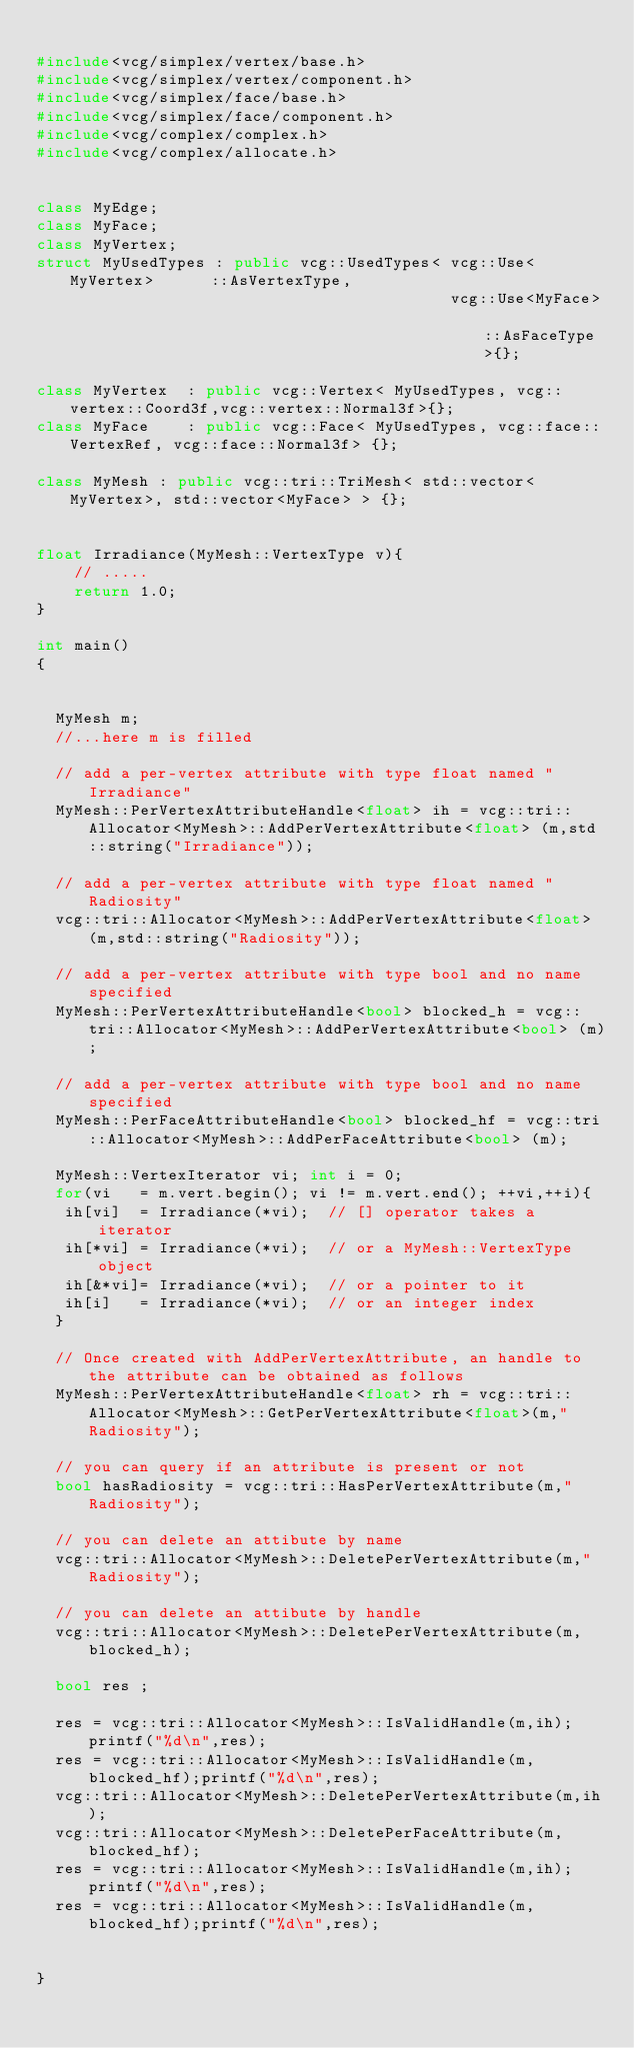Convert code to text. <code><loc_0><loc_0><loc_500><loc_500><_C++_>
#include<vcg/simplex/vertex/base.h>
#include<vcg/simplex/vertex/component.h>
#include<vcg/simplex/face/base.h>
#include<vcg/simplex/face/component.h>
#include<vcg/complex/complex.h>
#include<vcg/complex/allocate.h>


class MyEdge;
class MyFace;
class MyVertex;
struct MyUsedTypes : public vcg::UsedTypes<	vcg::Use<MyVertex>		::AsVertexType,
											vcg::Use<MyFace>			::AsFaceType>{};

class MyVertex  : public vcg::Vertex< MyUsedTypes, vcg::vertex::Coord3f,vcg::vertex::Normal3f>{};
class MyFace    : public vcg::Face< MyUsedTypes, vcg::face::VertexRef, vcg::face::Normal3f> {};

class MyMesh : public vcg::tri::TriMesh< std::vector<MyVertex>, std::vector<MyFace> > {};

 
float Irradiance(MyMesh::VertexType v){
	// .....
	return 1.0;
}

int main()
{


  MyMesh m;
  //...here m is filled
  
  // add a per-vertex attribute with type float named "Irradiance"
  MyMesh::PerVertexAttributeHandle<float> ih = vcg::tri::Allocator<MyMesh>::AddPerVertexAttribute<float> (m,std::string("Irradiance"));

  // add a per-vertex attribute with type float named "Radiosity"   
  vcg::tri::Allocator<MyMesh>::AddPerVertexAttribute<float> (m,std::string("Radiosity"));
 
  // add a per-vertex attribute with type bool and no name specified
  MyMesh::PerVertexAttributeHandle<bool> blocked_h = vcg::tri::Allocator<MyMesh>::AddPerVertexAttribute<bool> (m); 
  
  // add a per-vertex attribute with type bool and no name specified
  MyMesh::PerFaceAttributeHandle<bool> blocked_hf = vcg::tri::Allocator<MyMesh>::AddPerFaceAttribute<bool> (m); 

  MyMesh::VertexIterator vi; int i = 0;
  for(vi   = m.vert.begin(); vi != m.vert.end(); ++vi,++i){
   ih[vi]  = Irradiance(*vi);  // [] operator takes a iterator
   ih[*vi] = Irradiance(*vi);  // or a MyMesh::VertexType object
   ih[&*vi]= Irradiance(*vi);  // or a pointer to it
   ih[i]   = Irradiance(*vi);  // or an integer index
  }
    
  // Once created with AddPerVertexAttribute, an handle to the attribute can be obtained as follows
  MyMesh::PerVertexAttributeHandle<float> rh = vcg::tri::Allocator<MyMesh>::GetPerVertexAttribute<float>(m,"Radiosity");

  // you can query if an attribute is present or not
  bool hasRadiosity = vcg::tri::HasPerVertexAttribute(m,"Radiosity");

  // you can delete an attibute by name
  vcg::tri::Allocator<MyMesh>::DeletePerVertexAttribute(m,"Radiosity");

  // you can delete an attibute by handle
  vcg::tri::Allocator<MyMesh>::DeletePerVertexAttribute(m,blocked_h);

  bool res ;
 
  res = vcg::tri::Allocator<MyMesh>::IsValidHandle(m,ih);printf("%d\n",res);
  res = vcg::tri::Allocator<MyMesh>::IsValidHandle(m,blocked_hf);printf("%d\n",res);
  vcg::tri::Allocator<MyMesh>::DeletePerVertexAttribute(m,ih);
  vcg::tri::Allocator<MyMesh>::DeletePerFaceAttribute(m,blocked_hf);
  res = vcg::tri::Allocator<MyMesh>::IsValidHandle(m,ih);printf("%d\n",res);
  res = vcg::tri::Allocator<MyMesh>::IsValidHandle(m,blocked_hf);printf("%d\n",res);

 
}
</code> 